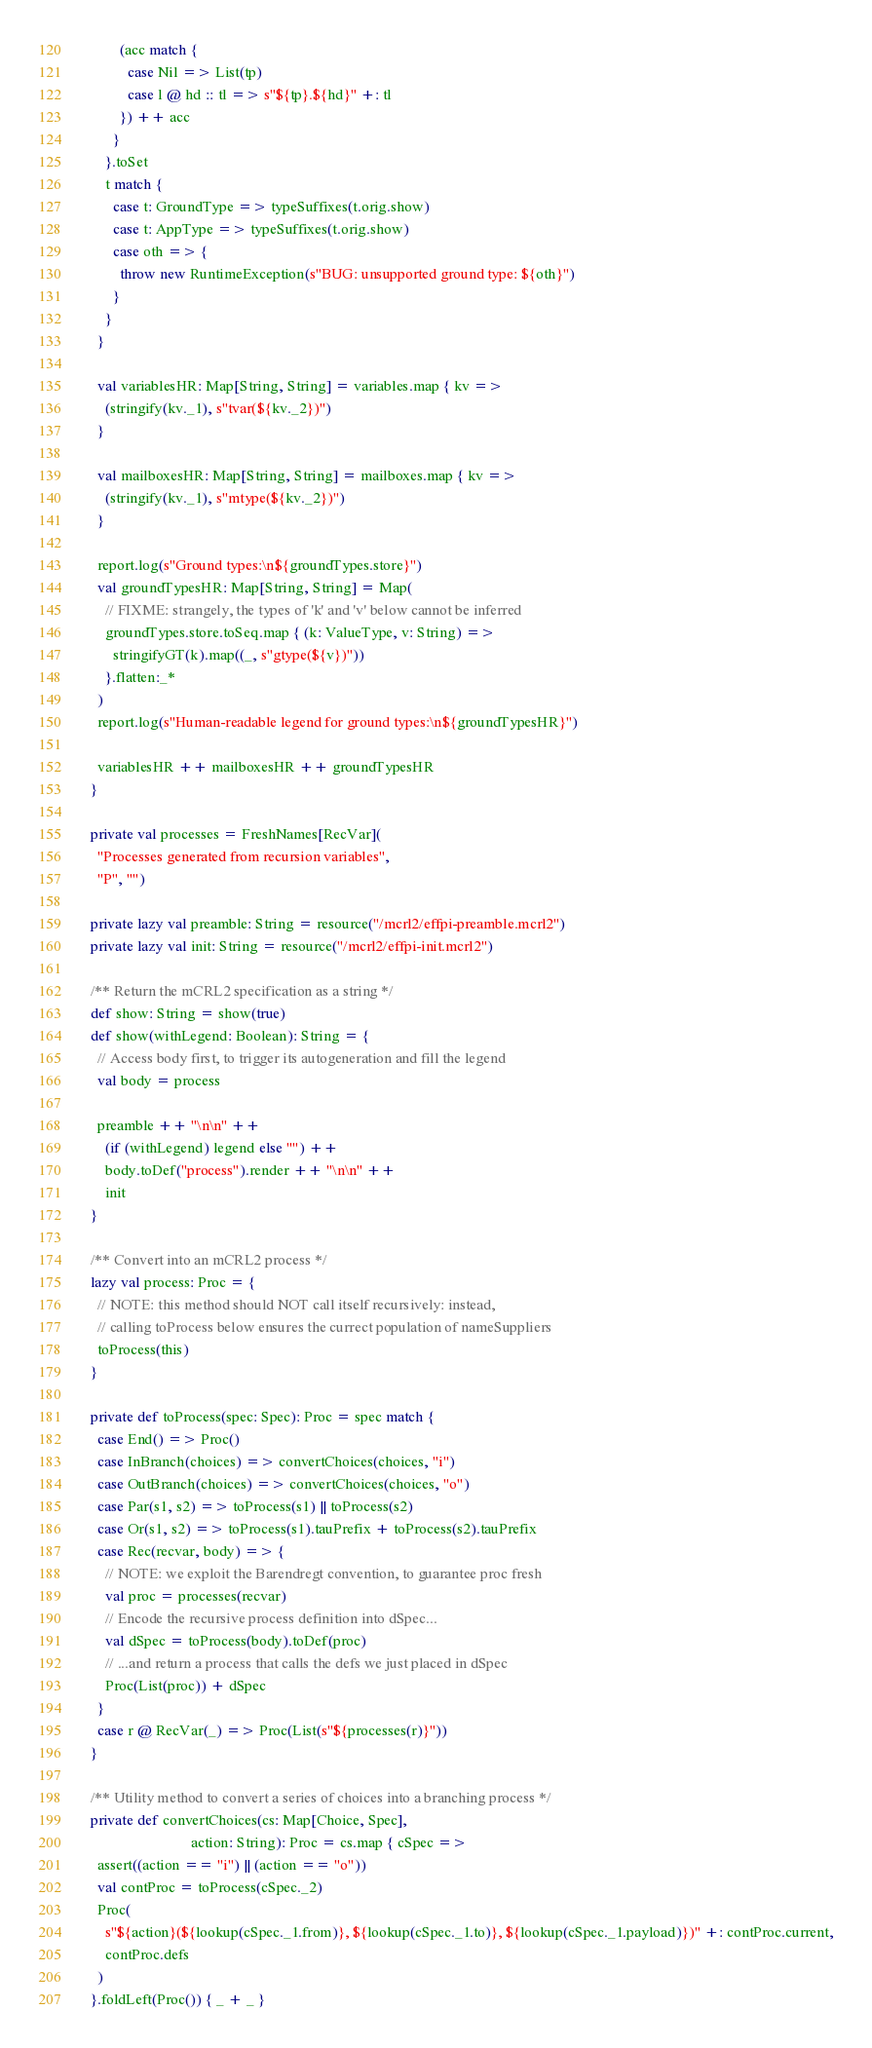Convert code to text. <code><loc_0><loc_0><loc_500><loc_500><_Scala_>          (acc match {
            case Nil => List(tp)
            case l @ hd :: tl => s"${tp}.${hd}" +: tl
          }) ++ acc
        }
      }.toSet
      t match {
        case t: GroundType => typeSuffixes(t.orig.show)
        case t: AppType => typeSuffixes(t.orig.show)
        case oth => {
          throw new RuntimeException(s"BUG: unsupported ground type: ${oth}")
        }
      }
    }

    val variablesHR: Map[String, String] = variables.map { kv =>
      (stringify(kv._1), s"tvar(${kv._2})")
    }

    val mailboxesHR: Map[String, String] = mailboxes.map { kv =>
      (stringify(kv._1), s"mtype(${kv._2})")
    }

    report.log(s"Ground types:\n${groundTypes.store}")
    val groundTypesHR: Map[String, String] = Map(
      // FIXME: strangely, the types of 'k' and 'v' below cannot be inferred
      groundTypes.store.toSeq.map { (k: ValueType, v: String) =>
        stringifyGT(k).map((_, s"gtype(${v})"))
      }.flatten:_*
    )
    report.log(s"Human-readable legend for ground types:\n${groundTypesHR}")

    variablesHR ++ mailboxesHR ++ groundTypesHR
  }

  private val processes = FreshNames[RecVar](
    "Processes generated from recursion variables",
    "P", "")

  private lazy val preamble: String = resource("/mcrl2/effpi-preamble.mcrl2")
  private lazy val init: String = resource("/mcrl2/effpi-init.mcrl2")

  /** Return the mCRL2 specification as a string */
  def show: String = show(true)
  def show(withLegend: Boolean): String = {
    // Access body first, to trigger its autogeneration and fill the legend
    val body = process

    preamble ++ "\n\n" ++
      (if (withLegend) legend else "") ++
      body.toDef("process").render ++ "\n\n" ++
      init
  }

  /** Convert into an mCRL2 process */
  lazy val process: Proc = {
    // NOTE: this method should NOT call itself recursively: instead,
    // calling toProcess below ensures the currect population of nameSuppliers
    toProcess(this)
  }
  
  private def toProcess(spec: Spec): Proc = spec match {
    case End() => Proc()
    case InBranch(choices) => convertChoices(choices, "i")
    case OutBranch(choices) => convertChoices(choices, "o")
    case Par(s1, s2) => toProcess(s1) || toProcess(s2)
    case Or(s1, s2) => toProcess(s1).tauPrefix + toProcess(s2).tauPrefix
    case Rec(recvar, body) => {
      // NOTE: we exploit the Barendregt convention, to guarantee proc fresh
      val proc = processes(recvar)
      // Encode the recursive process definition into dSpec...
      val dSpec = toProcess(body).toDef(proc)
      // ...and return a process that calls the defs we just placed in dSpec
      Proc(List(proc)) + dSpec
    }
    case r @ RecVar(_) => Proc(List(s"${processes(r)}"))
  }

  /** Utility method to convert a series of choices into a branching process */
  private def convertChoices(cs: Map[Choice, Spec],
                             action: String): Proc = cs.map { cSpec =>
    assert((action == "i") || (action == "o"))
    val contProc = toProcess(cSpec._2)
    Proc(
      s"${action}(${lookup(cSpec._1.from)}, ${lookup(cSpec._1.to)}, ${lookup(cSpec._1.payload)})" +: contProc.current,
      contProc.defs
    )
  }.foldLeft(Proc()) { _ + _ }
</code> 